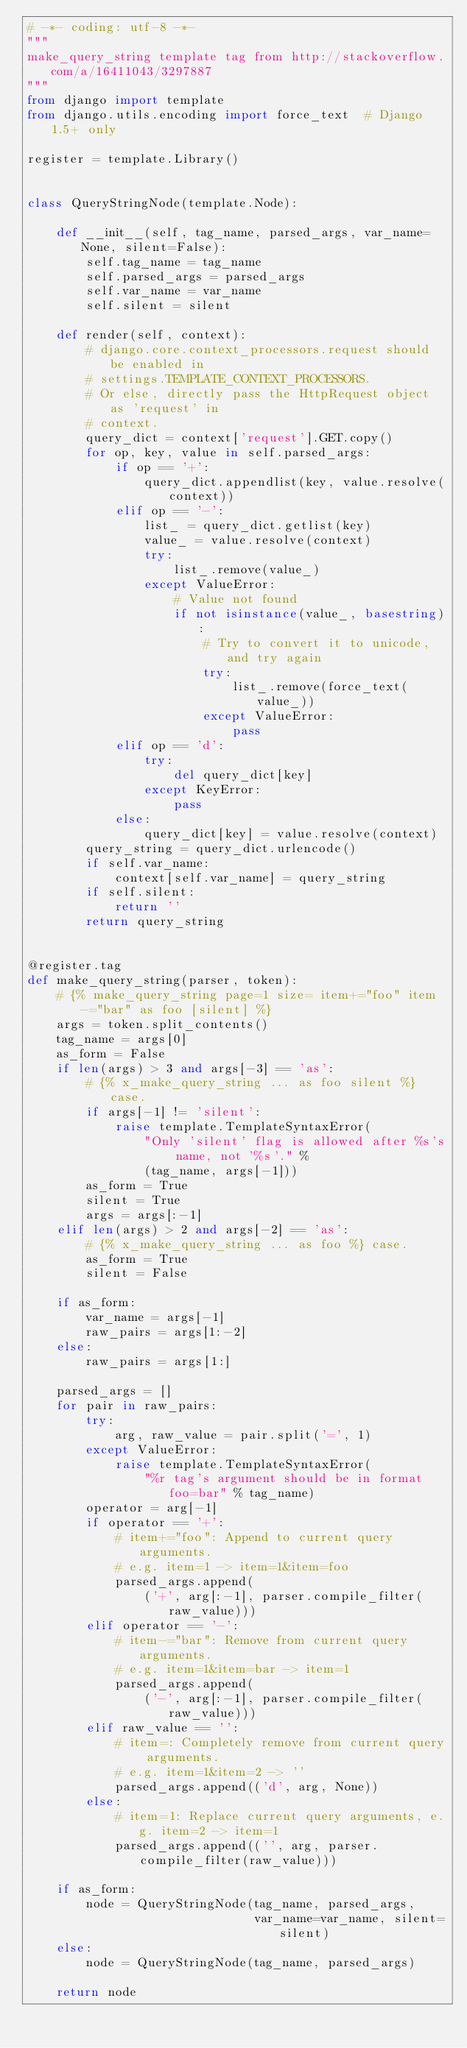<code> <loc_0><loc_0><loc_500><loc_500><_Python_># -*- coding: utf-8 -*-
"""
make_query_string template tag from http://stackoverflow.com/a/16411043/3297887
"""
from django import template
from django.utils.encoding import force_text  # Django 1.5+ only

register = template.Library()


class QueryStringNode(template.Node):

    def __init__(self, tag_name, parsed_args, var_name=None, silent=False):
        self.tag_name = tag_name
        self.parsed_args = parsed_args
        self.var_name = var_name
        self.silent = silent

    def render(self, context):
        # django.core.context_processors.request should be enabled in
        # settings.TEMPLATE_CONTEXT_PROCESSORS.
        # Or else, directly pass the HttpRequest object as 'request' in
        # context.
        query_dict = context['request'].GET.copy()
        for op, key, value in self.parsed_args:
            if op == '+':
                query_dict.appendlist(key, value.resolve(context))
            elif op == '-':
                list_ = query_dict.getlist(key)
                value_ = value.resolve(context)
                try:
                    list_.remove(value_)
                except ValueError:
                    # Value not found
                    if not isinstance(value_, basestring):
                        # Try to convert it to unicode, and try again
                        try:
                            list_.remove(force_text(value_))
                        except ValueError:
                            pass
            elif op == 'd':
                try:
                    del query_dict[key]
                except KeyError:
                    pass
            else:
                query_dict[key] = value.resolve(context)
        query_string = query_dict.urlencode()
        if self.var_name:
            context[self.var_name] = query_string
        if self.silent:
            return ''
        return query_string


@register.tag
def make_query_string(parser, token):
    # {% make_query_string page=1 size= item+="foo" item-="bar" as foo [silent] %}
    args = token.split_contents()
    tag_name = args[0]
    as_form = False
    if len(args) > 3 and args[-3] == 'as':
        # {% x_make_query_string ... as foo silent %} case.
        if args[-1] != 'silent':
            raise template.TemplateSyntaxError(
                "Only 'silent' flag is allowed after %s's name, not '%s'." %
                (tag_name, args[-1]))
        as_form = True
        silent = True
        args = args[:-1]
    elif len(args) > 2 and args[-2] == 'as':
        # {% x_make_query_string ... as foo %} case.
        as_form = True
        silent = False

    if as_form:
        var_name = args[-1]
        raw_pairs = args[1:-2]
    else:
        raw_pairs = args[1:]

    parsed_args = []
    for pair in raw_pairs:
        try:
            arg, raw_value = pair.split('=', 1)
        except ValueError:
            raise template.TemplateSyntaxError(
                "%r tag's argument should be in format foo=bar" % tag_name)
        operator = arg[-1]
        if operator == '+':
            # item+="foo": Append to current query arguments.
            # e.g. item=1 -> item=1&item=foo
            parsed_args.append(
                ('+', arg[:-1], parser.compile_filter(raw_value)))
        elif operator == '-':
            # item-="bar": Remove from current query arguments.
            # e.g. item=1&item=bar -> item=1
            parsed_args.append(
                ('-', arg[:-1], parser.compile_filter(raw_value)))
        elif raw_value == '':
            # item=: Completely remove from current query arguments.
            # e.g. item=1&item=2 -> ''
            parsed_args.append(('d', arg, None))
        else:
            # item=1: Replace current query arguments, e.g. item=2 -> item=1
            parsed_args.append(('', arg, parser.compile_filter(raw_value)))

    if as_form:
        node = QueryStringNode(tag_name, parsed_args,
                               var_name=var_name, silent=silent)
    else:
        node = QueryStringNode(tag_name, parsed_args)

    return node
</code> 